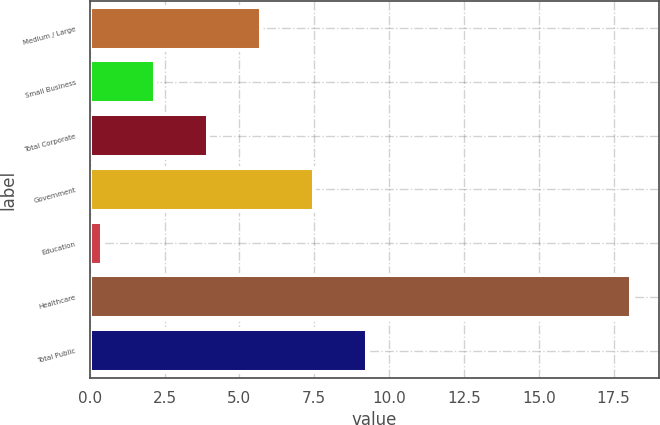<chart> <loc_0><loc_0><loc_500><loc_500><bar_chart><fcel>Medium / Large<fcel>Small Business<fcel>Total Corporate<fcel>Government<fcel>Education<fcel>Healthcare<fcel>Total Public<nl><fcel>5.71<fcel>2.17<fcel>3.94<fcel>7.48<fcel>0.4<fcel>18.1<fcel>9.25<nl></chart> 